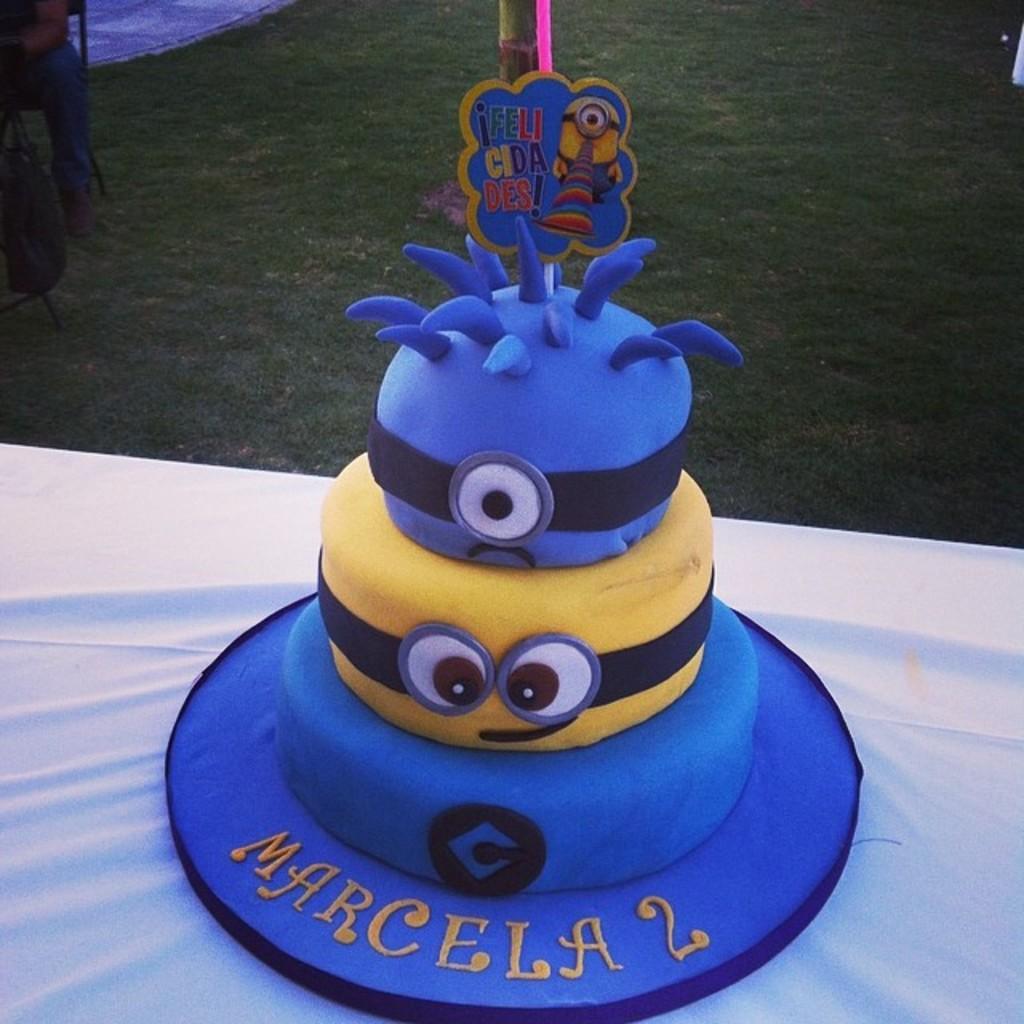How would you summarize this image in a sentence or two? In this image I can see a white colored surface on which I can see a cake which is blue, black and yellow in color. In the background I can see a person sitting on a chair, some grass, a pole and few other objects. 